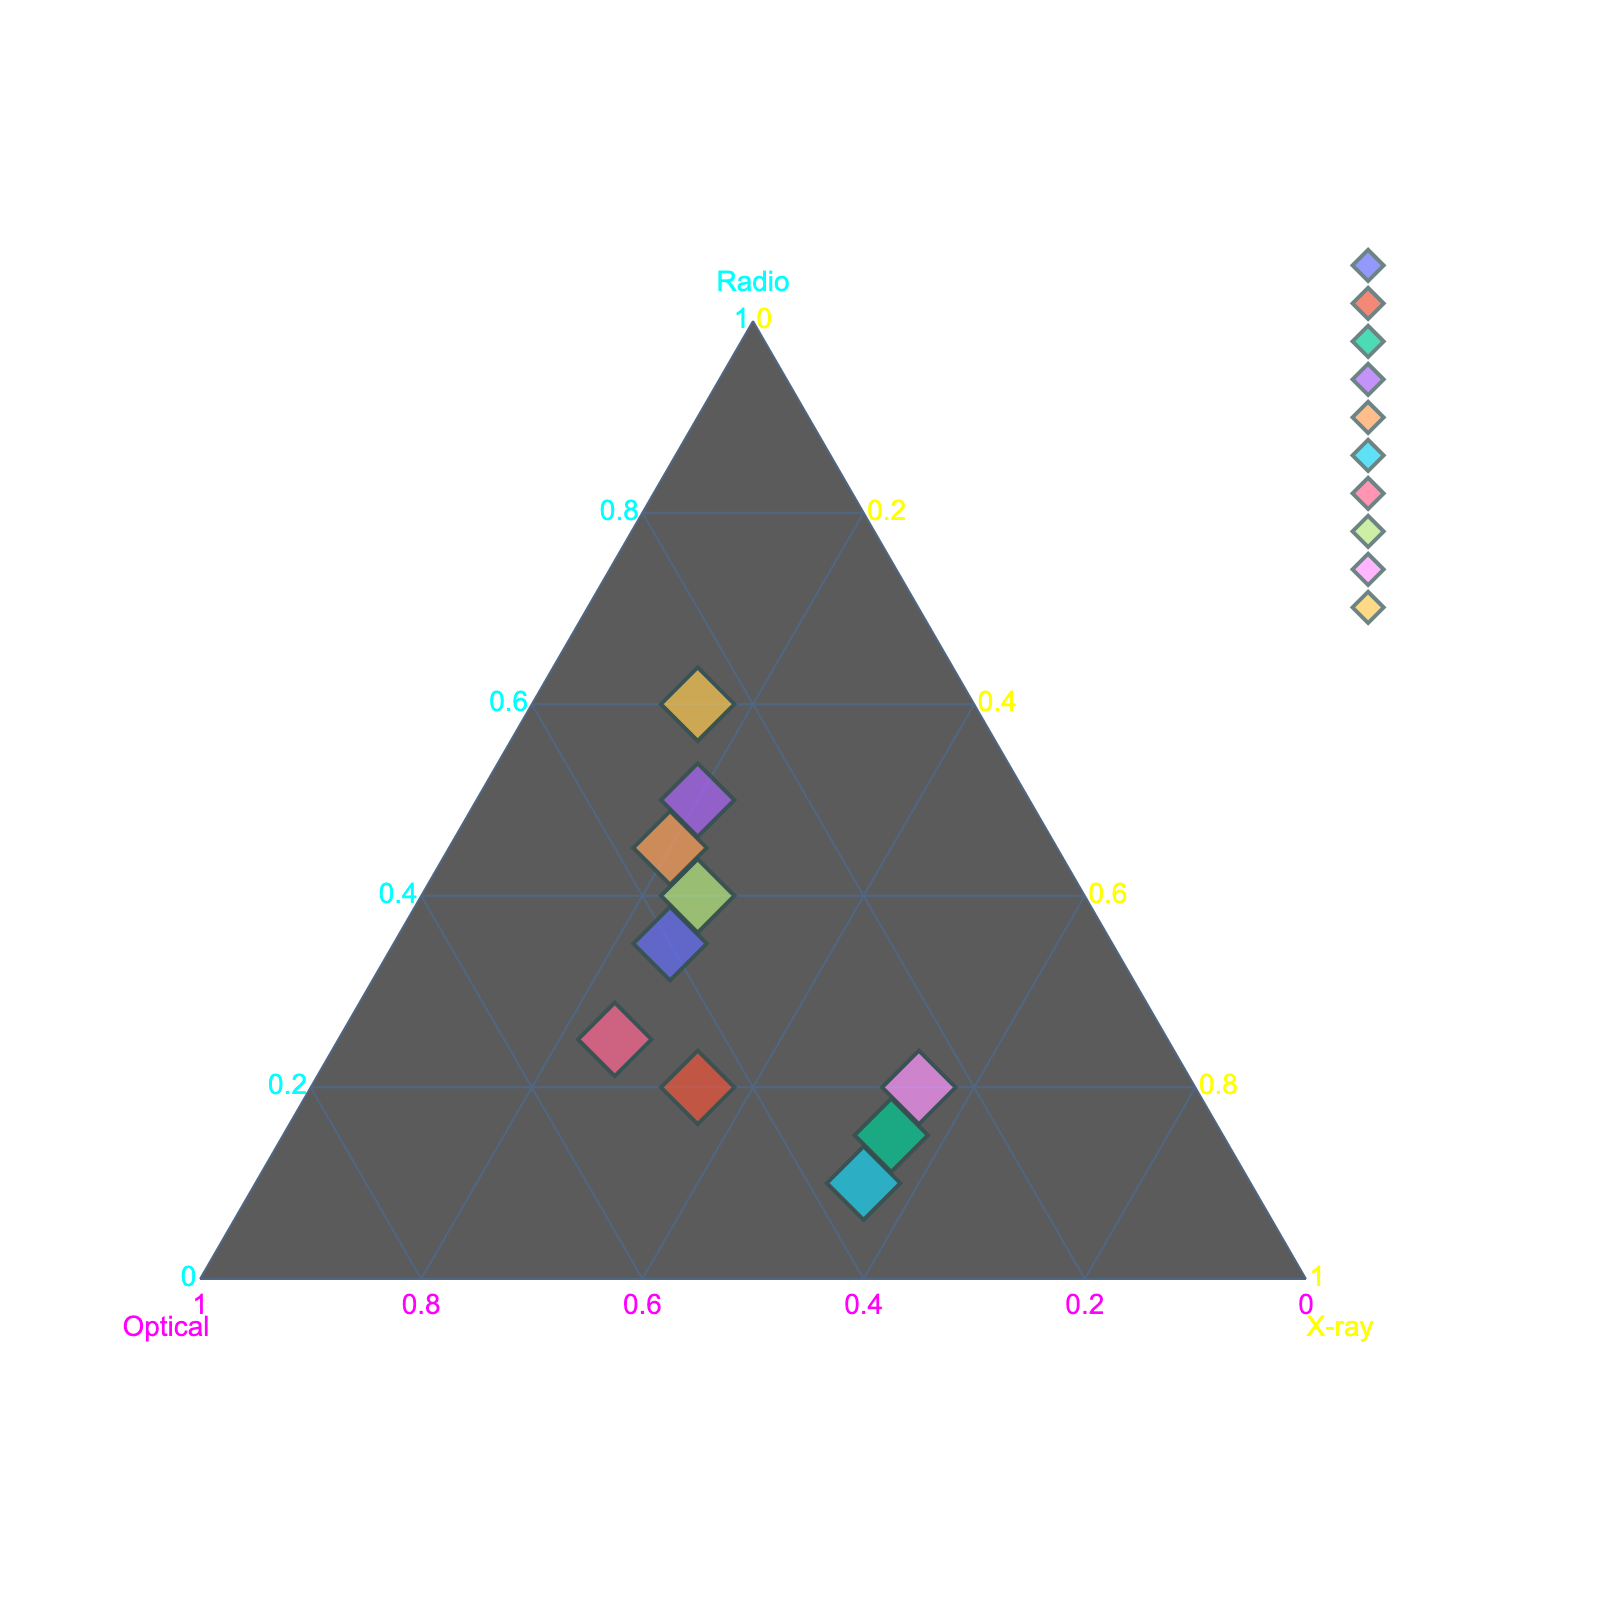What are the three axes on the ternary plot called? The ternary plot has three axes titled "Radio," "Optical," and "X-ray," which represent the normalized contributions of each spectral wavelength to the AGN spectral energy distributions.
Answer: Radio, Optical, X-ray How does the plot classify the object '3C 273'? The object '3C 273' is shown with approximately equal contributions from Radio, Optical, and X-ray wavelengths, with the proportion skewed slightly more towards Optical.
Answer: Balanced across all three with a slight skew towards Optical Which AGN has the highest contribution from Radio wavelengths? Cygnus A has the highest contribution from Radio wavelengths, positioned closest to the Radio axis.
Answer: Cygnus A Which AGNs have equal X-ray contributions? Both Mrk 421 and Mrk 501 have the highest and equal contributions from X-ray wavelengths, situating them closer to the X-ray axis.
Answer: Mrk 421 and Mrk 501 Between 'NGC 4151' and 'Mrk 421,' which AGN has a higher optical component? The 'NGC 4151' has a higher optical component compared to 'Mrk 421,' which is visible from its positioning closer to the Optical axis.
Answer: NGC 4151 What color scheme is used to distinguish the axes? The color scheme used for the axes includes cyan for Radio, magenta for Optical, and yellow for X-ray, making the distinctions clear.
Answer: Cyan, Magenta, Yellow Are there any AGNs where the contribution is equally split between two wavelengths? If so, which ones? Yes, '3C 273' and 'NGC 1068' have nearly equal contributions between Radio and Optical, and 'NGC 1068' shows almost equal contributions from Optical and X-ray.
Answer: 3C 273, NGC 1068 What is the ranking of AGNs based on their Optical contributions from highest to lowest? To rank them based on Optical contributions, start with the AGN closest to the Optical axis to the farthest. The ranking is NGC 1068 > NGC 4151 > Mrk 501 > PKS 2155-304 > 3C 273 > 3C 454.3 > Centaurus A > M87 > Cygnus A > Mrk 421.
Answer: NGC 1068, NGC 4151, Mrk 501, PKS 2155-304, 3C 273, 3C 454.3, Centaurus A, M87, Cygnus A, Mrk 421 Can you identify an AGN with balanced contributions from Radio and X-ray but less Optical? 'Centaurus A' shows balanced Radio and X-ray contributions with less Optical, as it lies closer to the Radio and X-ray axes and farther from the Optical.
Answer: Centaurus A 